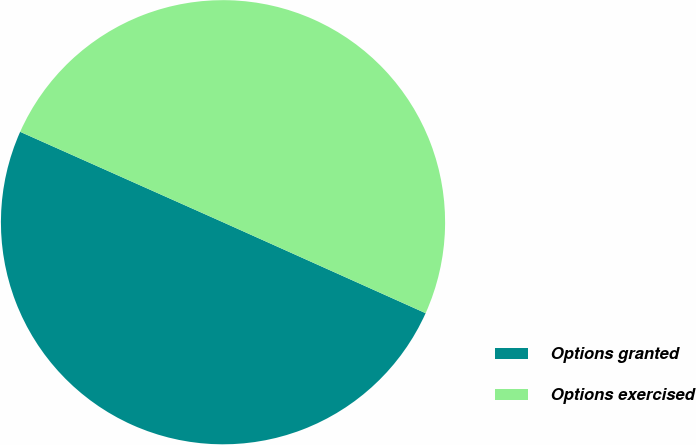<chart> <loc_0><loc_0><loc_500><loc_500><pie_chart><fcel>Options granted<fcel>Options exercised<nl><fcel>49.96%<fcel>50.04%<nl></chart> 